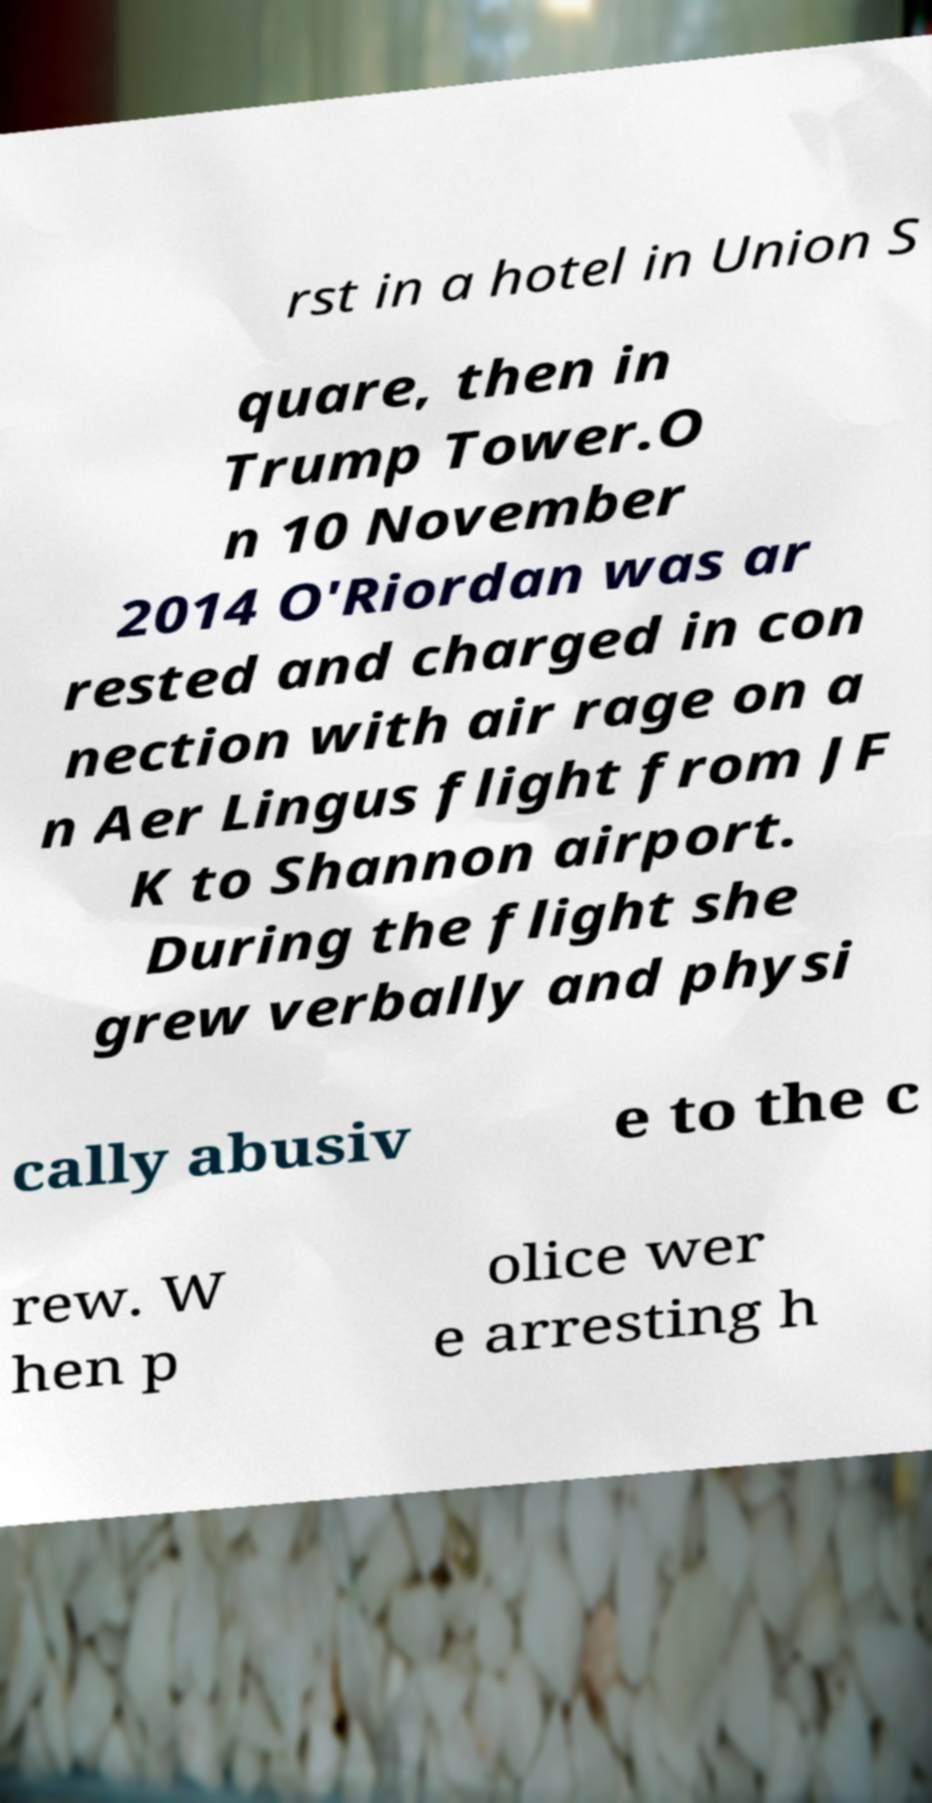For documentation purposes, I need the text within this image transcribed. Could you provide that? rst in a hotel in Union S quare, then in Trump Tower.O n 10 November 2014 O'Riordan was ar rested and charged in con nection with air rage on a n Aer Lingus flight from JF K to Shannon airport. During the flight she grew verbally and physi cally abusiv e to the c rew. W hen p olice wer e arresting h 